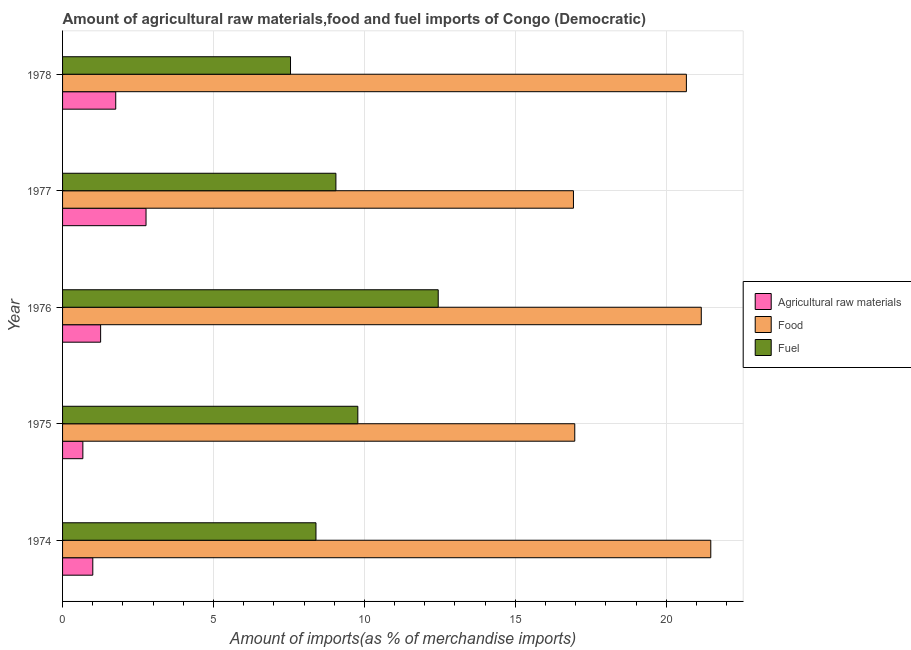How many different coloured bars are there?
Your answer should be very brief. 3. Are the number of bars on each tick of the Y-axis equal?
Provide a succinct answer. Yes. What is the label of the 4th group of bars from the top?
Ensure brevity in your answer.  1975. What is the percentage of raw materials imports in 1975?
Keep it short and to the point. 0.67. Across all years, what is the maximum percentage of raw materials imports?
Offer a terse response. 2.77. Across all years, what is the minimum percentage of fuel imports?
Make the answer very short. 7.55. In which year was the percentage of raw materials imports minimum?
Your response must be concise. 1975. What is the total percentage of raw materials imports in the graph?
Provide a short and direct response. 7.46. What is the difference between the percentage of food imports in 1974 and that in 1977?
Ensure brevity in your answer.  4.55. What is the difference between the percentage of raw materials imports in 1976 and the percentage of fuel imports in 1975?
Your response must be concise. -8.52. What is the average percentage of raw materials imports per year?
Your answer should be compact. 1.49. In the year 1976, what is the difference between the percentage of raw materials imports and percentage of fuel imports?
Your answer should be very brief. -11.18. In how many years, is the percentage of fuel imports greater than 20 %?
Keep it short and to the point. 0. What is the ratio of the percentage of raw materials imports in 1976 to that in 1977?
Provide a short and direct response. 0.46. What is the difference between the highest and the second highest percentage of fuel imports?
Your answer should be compact. 2.66. What is the difference between the highest and the lowest percentage of food imports?
Your response must be concise. 4.55. In how many years, is the percentage of raw materials imports greater than the average percentage of raw materials imports taken over all years?
Offer a very short reply. 2. What does the 3rd bar from the top in 1978 represents?
Keep it short and to the point. Agricultural raw materials. What does the 2nd bar from the bottom in 1978 represents?
Provide a succinct answer. Food. Is it the case that in every year, the sum of the percentage of raw materials imports and percentage of food imports is greater than the percentage of fuel imports?
Your answer should be compact. Yes. Are all the bars in the graph horizontal?
Make the answer very short. Yes. Are the values on the major ticks of X-axis written in scientific E-notation?
Provide a short and direct response. No. Does the graph contain any zero values?
Provide a succinct answer. No. Does the graph contain grids?
Ensure brevity in your answer.  Yes. Where does the legend appear in the graph?
Ensure brevity in your answer.  Center right. How many legend labels are there?
Offer a very short reply. 3. How are the legend labels stacked?
Provide a short and direct response. Vertical. What is the title of the graph?
Make the answer very short. Amount of agricultural raw materials,food and fuel imports of Congo (Democratic). Does "Maunufacturing" appear as one of the legend labels in the graph?
Give a very brief answer. No. What is the label or title of the X-axis?
Your answer should be very brief. Amount of imports(as % of merchandise imports). What is the Amount of imports(as % of merchandise imports) in Agricultural raw materials in 1974?
Your answer should be very brief. 1. What is the Amount of imports(as % of merchandise imports) in Food in 1974?
Your answer should be very brief. 21.47. What is the Amount of imports(as % of merchandise imports) of Fuel in 1974?
Your answer should be very brief. 8.39. What is the Amount of imports(as % of merchandise imports) of Agricultural raw materials in 1975?
Your response must be concise. 0.67. What is the Amount of imports(as % of merchandise imports) in Food in 1975?
Provide a succinct answer. 16.97. What is the Amount of imports(as % of merchandise imports) in Fuel in 1975?
Make the answer very short. 9.78. What is the Amount of imports(as % of merchandise imports) in Agricultural raw materials in 1976?
Your answer should be compact. 1.26. What is the Amount of imports(as % of merchandise imports) in Food in 1976?
Your answer should be compact. 21.16. What is the Amount of imports(as % of merchandise imports) of Fuel in 1976?
Give a very brief answer. 12.45. What is the Amount of imports(as % of merchandise imports) in Agricultural raw materials in 1977?
Provide a short and direct response. 2.77. What is the Amount of imports(as % of merchandise imports) of Food in 1977?
Your answer should be very brief. 16.93. What is the Amount of imports(as % of merchandise imports) of Fuel in 1977?
Ensure brevity in your answer.  9.06. What is the Amount of imports(as % of merchandise imports) of Agricultural raw materials in 1978?
Offer a very short reply. 1.76. What is the Amount of imports(as % of merchandise imports) of Food in 1978?
Ensure brevity in your answer.  20.67. What is the Amount of imports(as % of merchandise imports) in Fuel in 1978?
Your answer should be compact. 7.55. Across all years, what is the maximum Amount of imports(as % of merchandise imports) in Agricultural raw materials?
Offer a terse response. 2.77. Across all years, what is the maximum Amount of imports(as % of merchandise imports) of Food?
Your answer should be compact. 21.47. Across all years, what is the maximum Amount of imports(as % of merchandise imports) of Fuel?
Your response must be concise. 12.45. Across all years, what is the minimum Amount of imports(as % of merchandise imports) of Agricultural raw materials?
Provide a succinct answer. 0.67. Across all years, what is the minimum Amount of imports(as % of merchandise imports) in Food?
Offer a very short reply. 16.93. Across all years, what is the minimum Amount of imports(as % of merchandise imports) in Fuel?
Your response must be concise. 7.55. What is the total Amount of imports(as % of merchandise imports) of Agricultural raw materials in the graph?
Give a very brief answer. 7.46. What is the total Amount of imports(as % of merchandise imports) of Food in the graph?
Keep it short and to the point. 97.19. What is the total Amount of imports(as % of merchandise imports) in Fuel in the graph?
Your answer should be compact. 47.23. What is the difference between the Amount of imports(as % of merchandise imports) of Agricultural raw materials in 1974 and that in 1975?
Provide a succinct answer. 0.33. What is the difference between the Amount of imports(as % of merchandise imports) in Food in 1974 and that in 1975?
Offer a terse response. 4.51. What is the difference between the Amount of imports(as % of merchandise imports) in Fuel in 1974 and that in 1975?
Your response must be concise. -1.39. What is the difference between the Amount of imports(as % of merchandise imports) in Agricultural raw materials in 1974 and that in 1976?
Provide a short and direct response. -0.26. What is the difference between the Amount of imports(as % of merchandise imports) in Food in 1974 and that in 1976?
Your answer should be very brief. 0.31. What is the difference between the Amount of imports(as % of merchandise imports) in Fuel in 1974 and that in 1976?
Provide a succinct answer. -4.05. What is the difference between the Amount of imports(as % of merchandise imports) of Agricultural raw materials in 1974 and that in 1977?
Your answer should be very brief. -1.76. What is the difference between the Amount of imports(as % of merchandise imports) of Food in 1974 and that in 1977?
Offer a terse response. 4.55. What is the difference between the Amount of imports(as % of merchandise imports) of Fuel in 1974 and that in 1977?
Your answer should be very brief. -0.66. What is the difference between the Amount of imports(as % of merchandise imports) in Agricultural raw materials in 1974 and that in 1978?
Offer a very short reply. -0.76. What is the difference between the Amount of imports(as % of merchandise imports) in Food in 1974 and that in 1978?
Your answer should be very brief. 0.81. What is the difference between the Amount of imports(as % of merchandise imports) in Fuel in 1974 and that in 1978?
Give a very brief answer. 0.84. What is the difference between the Amount of imports(as % of merchandise imports) in Agricultural raw materials in 1975 and that in 1976?
Give a very brief answer. -0.59. What is the difference between the Amount of imports(as % of merchandise imports) in Food in 1975 and that in 1976?
Ensure brevity in your answer.  -4.19. What is the difference between the Amount of imports(as % of merchandise imports) in Fuel in 1975 and that in 1976?
Make the answer very short. -2.66. What is the difference between the Amount of imports(as % of merchandise imports) in Agricultural raw materials in 1975 and that in 1977?
Give a very brief answer. -2.09. What is the difference between the Amount of imports(as % of merchandise imports) of Food in 1975 and that in 1977?
Ensure brevity in your answer.  0.04. What is the difference between the Amount of imports(as % of merchandise imports) of Fuel in 1975 and that in 1977?
Your answer should be very brief. 0.73. What is the difference between the Amount of imports(as % of merchandise imports) of Agricultural raw materials in 1975 and that in 1978?
Make the answer very short. -1.09. What is the difference between the Amount of imports(as % of merchandise imports) in Food in 1975 and that in 1978?
Provide a succinct answer. -3.7. What is the difference between the Amount of imports(as % of merchandise imports) in Fuel in 1975 and that in 1978?
Make the answer very short. 2.23. What is the difference between the Amount of imports(as % of merchandise imports) of Agricultural raw materials in 1976 and that in 1977?
Offer a terse response. -1.5. What is the difference between the Amount of imports(as % of merchandise imports) in Food in 1976 and that in 1977?
Your answer should be very brief. 4.23. What is the difference between the Amount of imports(as % of merchandise imports) of Fuel in 1976 and that in 1977?
Give a very brief answer. 3.39. What is the difference between the Amount of imports(as % of merchandise imports) in Agricultural raw materials in 1976 and that in 1978?
Provide a succinct answer. -0.5. What is the difference between the Amount of imports(as % of merchandise imports) of Food in 1976 and that in 1978?
Your answer should be very brief. 0.49. What is the difference between the Amount of imports(as % of merchandise imports) of Fuel in 1976 and that in 1978?
Keep it short and to the point. 4.89. What is the difference between the Amount of imports(as % of merchandise imports) of Food in 1977 and that in 1978?
Make the answer very short. -3.74. What is the difference between the Amount of imports(as % of merchandise imports) in Fuel in 1977 and that in 1978?
Provide a short and direct response. 1.5. What is the difference between the Amount of imports(as % of merchandise imports) of Agricultural raw materials in 1974 and the Amount of imports(as % of merchandise imports) of Food in 1975?
Provide a succinct answer. -15.97. What is the difference between the Amount of imports(as % of merchandise imports) of Agricultural raw materials in 1974 and the Amount of imports(as % of merchandise imports) of Fuel in 1975?
Your answer should be compact. -8.78. What is the difference between the Amount of imports(as % of merchandise imports) in Food in 1974 and the Amount of imports(as % of merchandise imports) in Fuel in 1975?
Give a very brief answer. 11.69. What is the difference between the Amount of imports(as % of merchandise imports) in Agricultural raw materials in 1974 and the Amount of imports(as % of merchandise imports) in Food in 1976?
Your response must be concise. -20.16. What is the difference between the Amount of imports(as % of merchandise imports) in Agricultural raw materials in 1974 and the Amount of imports(as % of merchandise imports) in Fuel in 1976?
Your response must be concise. -11.44. What is the difference between the Amount of imports(as % of merchandise imports) of Food in 1974 and the Amount of imports(as % of merchandise imports) of Fuel in 1976?
Ensure brevity in your answer.  9.03. What is the difference between the Amount of imports(as % of merchandise imports) of Agricultural raw materials in 1974 and the Amount of imports(as % of merchandise imports) of Food in 1977?
Offer a terse response. -15.92. What is the difference between the Amount of imports(as % of merchandise imports) of Agricultural raw materials in 1974 and the Amount of imports(as % of merchandise imports) of Fuel in 1977?
Ensure brevity in your answer.  -8.05. What is the difference between the Amount of imports(as % of merchandise imports) of Food in 1974 and the Amount of imports(as % of merchandise imports) of Fuel in 1977?
Offer a very short reply. 12.42. What is the difference between the Amount of imports(as % of merchandise imports) of Agricultural raw materials in 1974 and the Amount of imports(as % of merchandise imports) of Food in 1978?
Offer a very short reply. -19.67. What is the difference between the Amount of imports(as % of merchandise imports) of Agricultural raw materials in 1974 and the Amount of imports(as % of merchandise imports) of Fuel in 1978?
Keep it short and to the point. -6.55. What is the difference between the Amount of imports(as % of merchandise imports) in Food in 1974 and the Amount of imports(as % of merchandise imports) in Fuel in 1978?
Give a very brief answer. 13.92. What is the difference between the Amount of imports(as % of merchandise imports) of Agricultural raw materials in 1975 and the Amount of imports(as % of merchandise imports) of Food in 1976?
Offer a terse response. -20.49. What is the difference between the Amount of imports(as % of merchandise imports) of Agricultural raw materials in 1975 and the Amount of imports(as % of merchandise imports) of Fuel in 1976?
Your answer should be compact. -11.77. What is the difference between the Amount of imports(as % of merchandise imports) of Food in 1975 and the Amount of imports(as % of merchandise imports) of Fuel in 1976?
Your answer should be very brief. 4.52. What is the difference between the Amount of imports(as % of merchandise imports) in Agricultural raw materials in 1975 and the Amount of imports(as % of merchandise imports) in Food in 1977?
Your answer should be compact. -16.25. What is the difference between the Amount of imports(as % of merchandise imports) in Agricultural raw materials in 1975 and the Amount of imports(as % of merchandise imports) in Fuel in 1977?
Give a very brief answer. -8.38. What is the difference between the Amount of imports(as % of merchandise imports) of Food in 1975 and the Amount of imports(as % of merchandise imports) of Fuel in 1977?
Give a very brief answer. 7.91. What is the difference between the Amount of imports(as % of merchandise imports) in Agricultural raw materials in 1975 and the Amount of imports(as % of merchandise imports) in Food in 1978?
Give a very brief answer. -19.99. What is the difference between the Amount of imports(as % of merchandise imports) of Agricultural raw materials in 1975 and the Amount of imports(as % of merchandise imports) of Fuel in 1978?
Give a very brief answer. -6.88. What is the difference between the Amount of imports(as % of merchandise imports) in Food in 1975 and the Amount of imports(as % of merchandise imports) in Fuel in 1978?
Make the answer very short. 9.42. What is the difference between the Amount of imports(as % of merchandise imports) in Agricultural raw materials in 1976 and the Amount of imports(as % of merchandise imports) in Food in 1977?
Keep it short and to the point. -15.66. What is the difference between the Amount of imports(as % of merchandise imports) of Agricultural raw materials in 1976 and the Amount of imports(as % of merchandise imports) of Fuel in 1977?
Ensure brevity in your answer.  -7.79. What is the difference between the Amount of imports(as % of merchandise imports) of Food in 1976 and the Amount of imports(as % of merchandise imports) of Fuel in 1977?
Ensure brevity in your answer.  12.1. What is the difference between the Amount of imports(as % of merchandise imports) in Agricultural raw materials in 1976 and the Amount of imports(as % of merchandise imports) in Food in 1978?
Offer a terse response. -19.41. What is the difference between the Amount of imports(as % of merchandise imports) of Agricultural raw materials in 1976 and the Amount of imports(as % of merchandise imports) of Fuel in 1978?
Provide a succinct answer. -6.29. What is the difference between the Amount of imports(as % of merchandise imports) of Food in 1976 and the Amount of imports(as % of merchandise imports) of Fuel in 1978?
Your response must be concise. 13.61. What is the difference between the Amount of imports(as % of merchandise imports) of Agricultural raw materials in 1977 and the Amount of imports(as % of merchandise imports) of Food in 1978?
Keep it short and to the point. -17.9. What is the difference between the Amount of imports(as % of merchandise imports) of Agricultural raw materials in 1977 and the Amount of imports(as % of merchandise imports) of Fuel in 1978?
Keep it short and to the point. -4.79. What is the difference between the Amount of imports(as % of merchandise imports) of Food in 1977 and the Amount of imports(as % of merchandise imports) of Fuel in 1978?
Give a very brief answer. 9.37. What is the average Amount of imports(as % of merchandise imports) in Agricultural raw materials per year?
Your answer should be very brief. 1.49. What is the average Amount of imports(as % of merchandise imports) in Food per year?
Provide a succinct answer. 19.44. What is the average Amount of imports(as % of merchandise imports) in Fuel per year?
Give a very brief answer. 9.45. In the year 1974, what is the difference between the Amount of imports(as % of merchandise imports) in Agricultural raw materials and Amount of imports(as % of merchandise imports) in Food?
Make the answer very short. -20.47. In the year 1974, what is the difference between the Amount of imports(as % of merchandise imports) of Agricultural raw materials and Amount of imports(as % of merchandise imports) of Fuel?
Ensure brevity in your answer.  -7.39. In the year 1974, what is the difference between the Amount of imports(as % of merchandise imports) of Food and Amount of imports(as % of merchandise imports) of Fuel?
Offer a terse response. 13.08. In the year 1975, what is the difference between the Amount of imports(as % of merchandise imports) in Agricultural raw materials and Amount of imports(as % of merchandise imports) in Food?
Offer a very short reply. -16.3. In the year 1975, what is the difference between the Amount of imports(as % of merchandise imports) of Agricultural raw materials and Amount of imports(as % of merchandise imports) of Fuel?
Keep it short and to the point. -9.11. In the year 1975, what is the difference between the Amount of imports(as % of merchandise imports) in Food and Amount of imports(as % of merchandise imports) in Fuel?
Provide a short and direct response. 7.19. In the year 1976, what is the difference between the Amount of imports(as % of merchandise imports) of Agricultural raw materials and Amount of imports(as % of merchandise imports) of Food?
Give a very brief answer. -19.9. In the year 1976, what is the difference between the Amount of imports(as % of merchandise imports) in Agricultural raw materials and Amount of imports(as % of merchandise imports) in Fuel?
Give a very brief answer. -11.18. In the year 1976, what is the difference between the Amount of imports(as % of merchandise imports) of Food and Amount of imports(as % of merchandise imports) of Fuel?
Keep it short and to the point. 8.71. In the year 1977, what is the difference between the Amount of imports(as % of merchandise imports) of Agricultural raw materials and Amount of imports(as % of merchandise imports) of Food?
Ensure brevity in your answer.  -14.16. In the year 1977, what is the difference between the Amount of imports(as % of merchandise imports) of Agricultural raw materials and Amount of imports(as % of merchandise imports) of Fuel?
Offer a terse response. -6.29. In the year 1977, what is the difference between the Amount of imports(as % of merchandise imports) in Food and Amount of imports(as % of merchandise imports) in Fuel?
Offer a terse response. 7.87. In the year 1978, what is the difference between the Amount of imports(as % of merchandise imports) in Agricultural raw materials and Amount of imports(as % of merchandise imports) in Food?
Provide a succinct answer. -18.91. In the year 1978, what is the difference between the Amount of imports(as % of merchandise imports) of Agricultural raw materials and Amount of imports(as % of merchandise imports) of Fuel?
Your answer should be compact. -5.79. In the year 1978, what is the difference between the Amount of imports(as % of merchandise imports) in Food and Amount of imports(as % of merchandise imports) in Fuel?
Your answer should be compact. 13.11. What is the ratio of the Amount of imports(as % of merchandise imports) of Agricultural raw materials in 1974 to that in 1975?
Your answer should be compact. 1.49. What is the ratio of the Amount of imports(as % of merchandise imports) of Food in 1974 to that in 1975?
Offer a terse response. 1.27. What is the ratio of the Amount of imports(as % of merchandise imports) of Fuel in 1974 to that in 1975?
Your answer should be very brief. 0.86. What is the ratio of the Amount of imports(as % of merchandise imports) in Agricultural raw materials in 1974 to that in 1976?
Keep it short and to the point. 0.79. What is the ratio of the Amount of imports(as % of merchandise imports) in Food in 1974 to that in 1976?
Give a very brief answer. 1.01. What is the ratio of the Amount of imports(as % of merchandise imports) in Fuel in 1974 to that in 1976?
Offer a terse response. 0.67. What is the ratio of the Amount of imports(as % of merchandise imports) of Agricultural raw materials in 1974 to that in 1977?
Offer a terse response. 0.36. What is the ratio of the Amount of imports(as % of merchandise imports) of Food in 1974 to that in 1977?
Provide a succinct answer. 1.27. What is the ratio of the Amount of imports(as % of merchandise imports) in Fuel in 1974 to that in 1977?
Make the answer very short. 0.93. What is the ratio of the Amount of imports(as % of merchandise imports) in Agricultural raw materials in 1974 to that in 1978?
Offer a terse response. 0.57. What is the ratio of the Amount of imports(as % of merchandise imports) of Food in 1974 to that in 1978?
Offer a very short reply. 1.04. What is the ratio of the Amount of imports(as % of merchandise imports) in Fuel in 1974 to that in 1978?
Give a very brief answer. 1.11. What is the ratio of the Amount of imports(as % of merchandise imports) of Agricultural raw materials in 1975 to that in 1976?
Your answer should be compact. 0.53. What is the ratio of the Amount of imports(as % of merchandise imports) in Food in 1975 to that in 1976?
Ensure brevity in your answer.  0.8. What is the ratio of the Amount of imports(as % of merchandise imports) of Fuel in 1975 to that in 1976?
Ensure brevity in your answer.  0.79. What is the ratio of the Amount of imports(as % of merchandise imports) in Agricultural raw materials in 1975 to that in 1977?
Make the answer very short. 0.24. What is the ratio of the Amount of imports(as % of merchandise imports) in Fuel in 1975 to that in 1977?
Ensure brevity in your answer.  1.08. What is the ratio of the Amount of imports(as % of merchandise imports) of Agricultural raw materials in 1975 to that in 1978?
Your answer should be very brief. 0.38. What is the ratio of the Amount of imports(as % of merchandise imports) in Food in 1975 to that in 1978?
Give a very brief answer. 0.82. What is the ratio of the Amount of imports(as % of merchandise imports) in Fuel in 1975 to that in 1978?
Ensure brevity in your answer.  1.3. What is the ratio of the Amount of imports(as % of merchandise imports) in Agricultural raw materials in 1976 to that in 1977?
Your answer should be very brief. 0.46. What is the ratio of the Amount of imports(as % of merchandise imports) in Food in 1976 to that in 1977?
Your response must be concise. 1.25. What is the ratio of the Amount of imports(as % of merchandise imports) in Fuel in 1976 to that in 1977?
Offer a terse response. 1.37. What is the ratio of the Amount of imports(as % of merchandise imports) in Agricultural raw materials in 1976 to that in 1978?
Your answer should be compact. 0.72. What is the ratio of the Amount of imports(as % of merchandise imports) in Food in 1976 to that in 1978?
Your answer should be compact. 1.02. What is the ratio of the Amount of imports(as % of merchandise imports) in Fuel in 1976 to that in 1978?
Your answer should be compact. 1.65. What is the ratio of the Amount of imports(as % of merchandise imports) of Agricultural raw materials in 1977 to that in 1978?
Your response must be concise. 1.57. What is the ratio of the Amount of imports(as % of merchandise imports) of Food in 1977 to that in 1978?
Make the answer very short. 0.82. What is the ratio of the Amount of imports(as % of merchandise imports) in Fuel in 1977 to that in 1978?
Your response must be concise. 1.2. What is the difference between the highest and the second highest Amount of imports(as % of merchandise imports) in Food?
Your answer should be compact. 0.31. What is the difference between the highest and the second highest Amount of imports(as % of merchandise imports) in Fuel?
Offer a terse response. 2.66. What is the difference between the highest and the lowest Amount of imports(as % of merchandise imports) in Agricultural raw materials?
Your answer should be compact. 2.09. What is the difference between the highest and the lowest Amount of imports(as % of merchandise imports) of Food?
Offer a terse response. 4.55. What is the difference between the highest and the lowest Amount of imports(as % of merchandise imports) of Fuel?
Offer a very short reply. 4.89. 